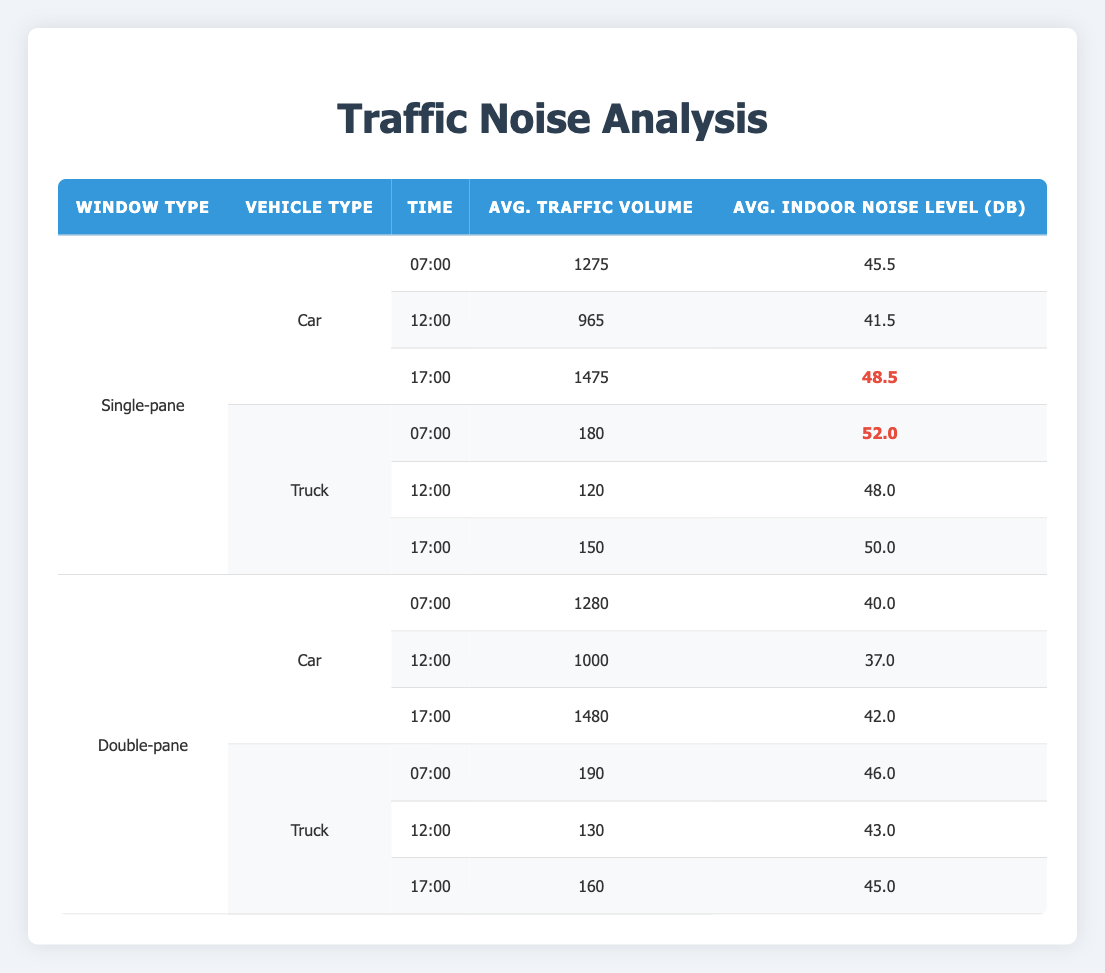What is the indoor noise level for Single-pane windows at 17:00? According to the table, the indoor noise level associated with Single-pane windows at 17:00 is 48.5 dB.
Answer: 48.5 dB What is the average traffic volume for Double-pane windows at 12:00? The table lists the traffic volume for Double-pane windows at 12:00 as 1000.
Answer: 1000 Is the average indoor noise level higher for Trucks or Cars during the 07:00 time slot? For Trucks, the indoor noise level at 07:00 is 52.0 dB, while for Cars it is 45.5 dB. Since 52.0 > 45.5, the average noise level for Trucks is higher.
Answer: Yes What is the difference in average indoor noise levels between Single-pane and Double-pane windows for Cars at 12:00? The average indoor noise level for Single-pane windows at 12:00 is 41.5 dB, and for Double-pane it's 37.0 dB. The difference is 41.5 - 37.0 = 4.5 dB.
Answer: 4.5 dB On which day and time was the highest traffic volume recorded? The highest traffic volume recorded in the data is 1500, occurring on 2023-05-02 at 17:00.
Answer: 2023-05-02 at 17:00 What is the average indoor noise level for Trucks during the 17:00 time slot? The table shows the average indoor noise levels for Trucks at 17:00 as 50.0 dB.
Answer: 50.0 dB Are indoor noise levels affected by the window type when comparing cars at 07:00? Yes, the indoor noise level for Cars at 07:00 with Single-pane windows is 45.5 dB, while for Double-pane windows it is 40.0 dB, indicating that window type affects noise levels.
Answer: Yes What's the average indoor noise level during peak traffic hours (17:00) across all vehicle types and window types? From the table, the averages for 17:00 are: Single-pane Car (48.5), Single-pane Truck (50.0), Double-pane Car (42.0), and Double-pane Truck (45.0). The total is 48.5 + 50.0 + 42.0 + 45.0 = 185.5 dB, and with 4 instances, the average is 185.5 / 4 = 46.375 dB.
Answer: 46.375 dB 